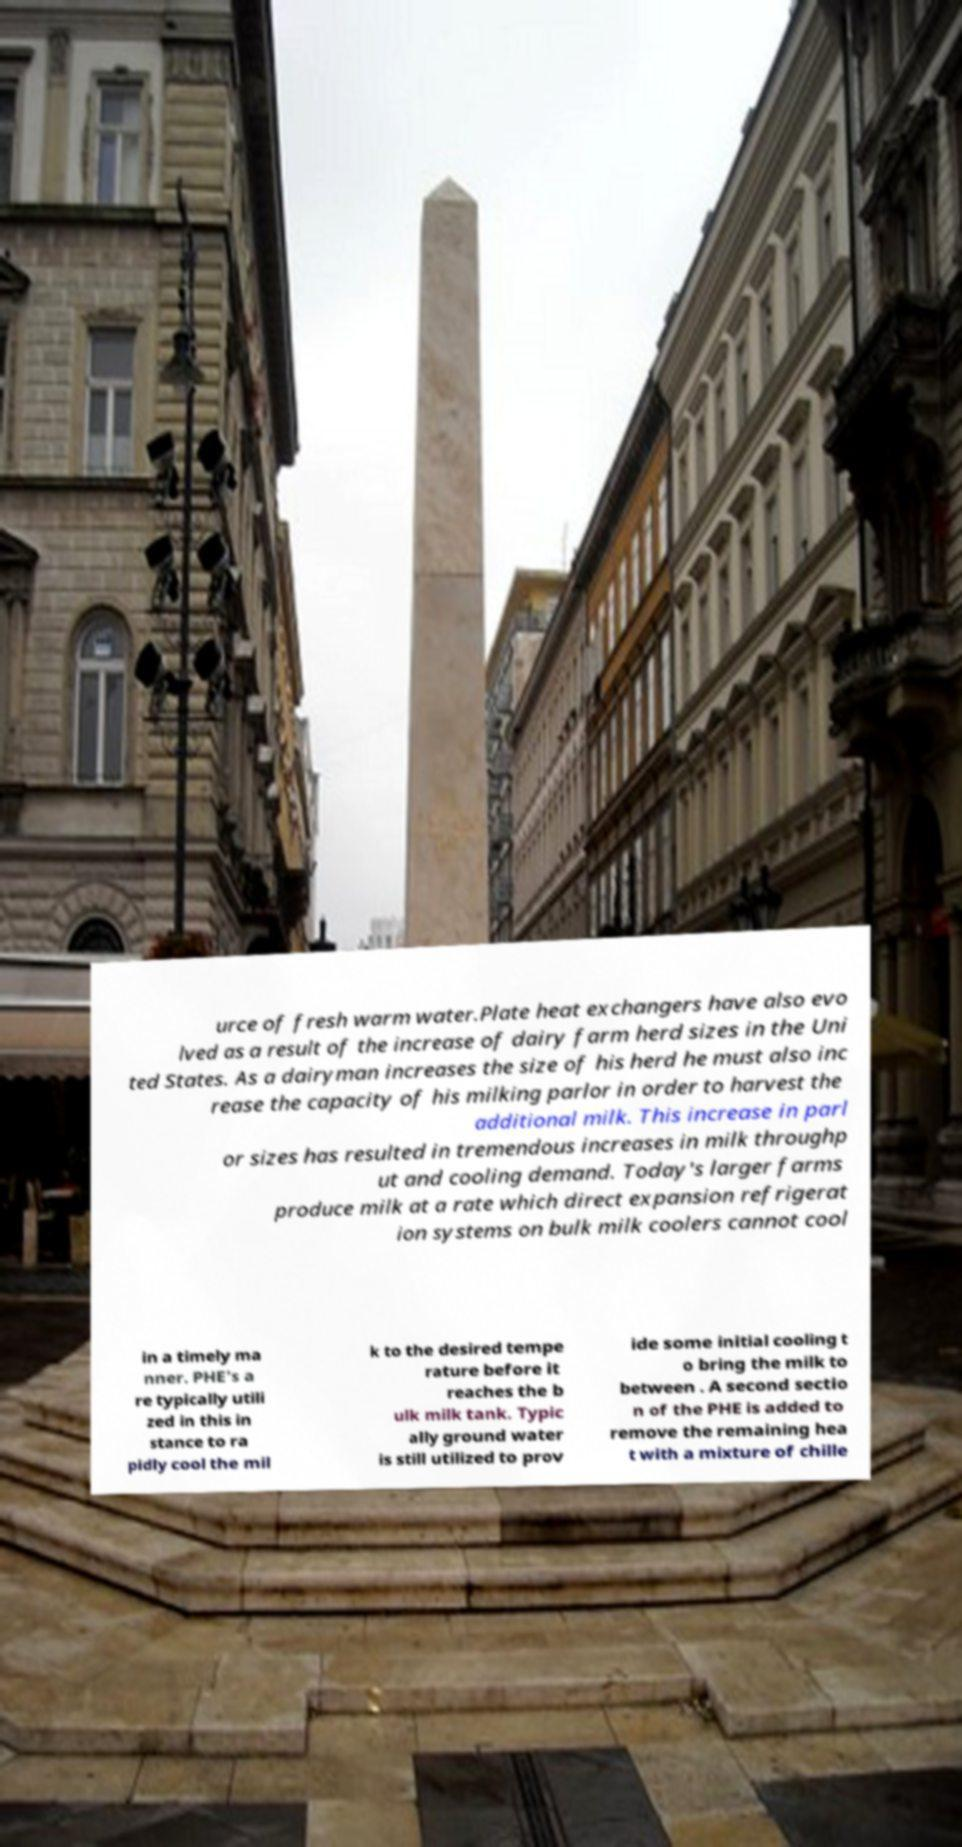Could you extract and type out the text from this image? urce of fresh warm water.Plate heat exchangers have also evo lved as a result of the increase of dairy farm herd sizes in the Uni ted States. As a dairyman increases the size of his herd he must also inc rease the capacity of his milking parlor in order to harvest the additional milk. This increase in parl or sizes has resulted in tremendous increases in milk throughp ut and cooling demand. Today's larger farms produce milk at a rate which direct expansion refrigerat ion systems on bulk milk coolers cannot cool in a timely ma nner. PHE's a re typically utili zed in this in stance to ra pidly cool the mil k to the desired tempe rature before it reaches the b ulk milk tank. Typic ally ground water is still utilized to prov ide some initial cooling t o bring the milk to between . A second sectio n of the PHE is added to remove the remaining hea t with a mixture of chille 